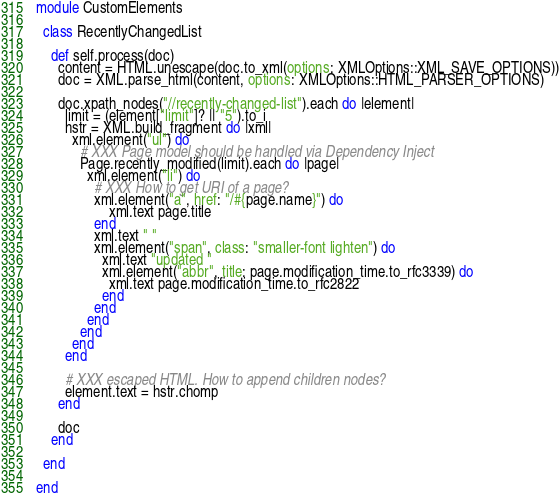<code> <loc_0><loc_0><loc_500><loc_500><_Crystal_>module CustomElements

  class RecentlyChangedList

    def self.process(doc)
      content = HTML.unescape(doc.to_xml(options: XMLOptions::XML_SAVE_OPTIONS))
      doc = XML.parse_html(content, options: XMLOptions::HTML_PARSER_OPTIONS)

      doc.xpath_nodes("//recently-changed-list").each do |element|
        limit = (element["limit"]? || "5").to_i
        hstr = XML.build_fragment do |xml|
          xml.element("ul") do
            # XXX Page model should be handled via Dependency Inject
            Page.recently_modified(limit).each do |page|
              xml.element("li") do
                # XXX How to get URI of a page?
                xml.element("a", href: "/#{page.name}") do
                    xml.text page.title
                end
                xml.text " "
                xml.element("span", class: "smaller-font lighten") do
                  xml.text "updated "
                  xml.element("abbr", title: page.modification_time.to_rfc3339) do
                    xml.text page.modification_time.to_rfc2822
                  end
                end
              end
            end
          end
        end

        # XXX escaped HTML. How to append children nodes?
        element.text = hstr.chomp
      end

      doc
    end

  end

end
</code> 